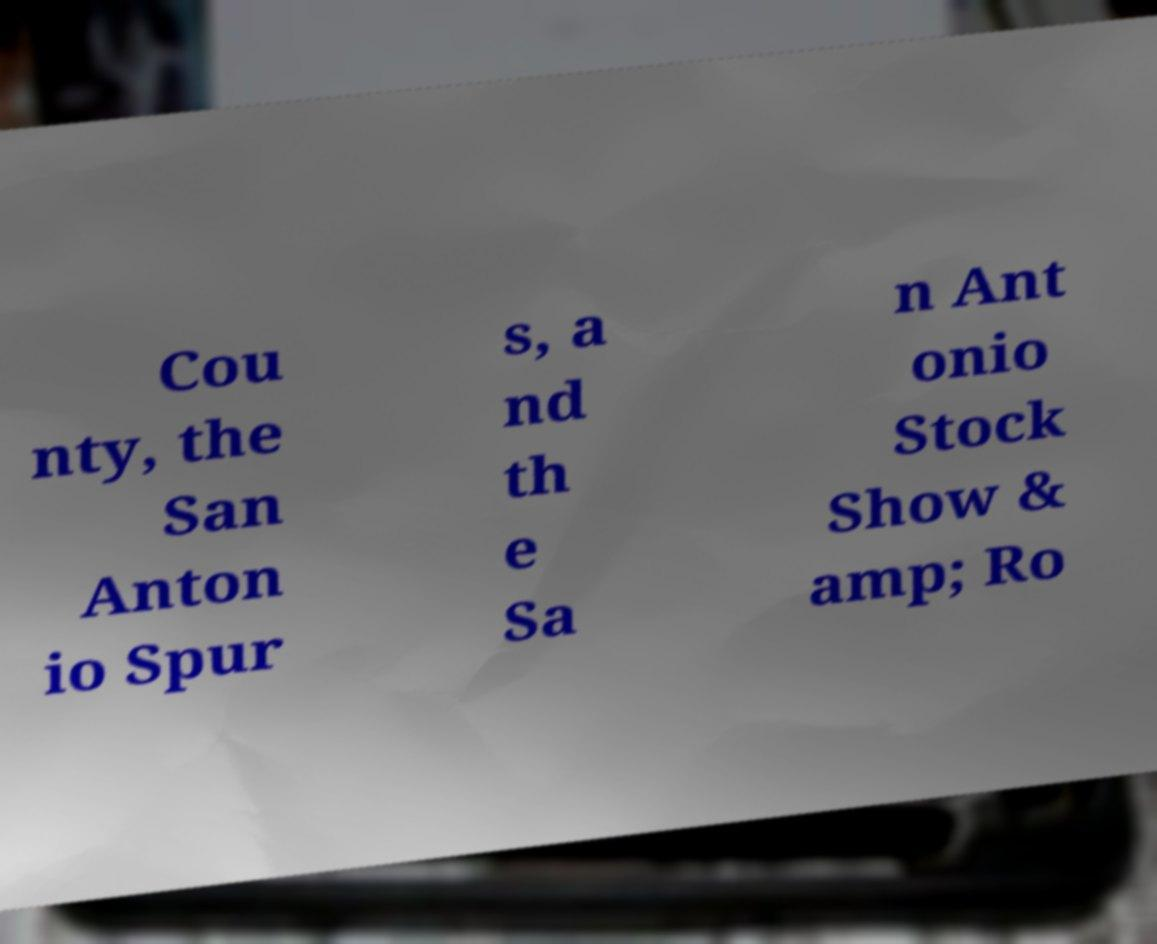Can you read and provide the text displayed in the image?This photo seems to have some interesting text. Can you extract and type it out for me? Cou nty, the San Anton io Spur s, a nd th e Sa n Ant onio Stock Show & amp; Ro 